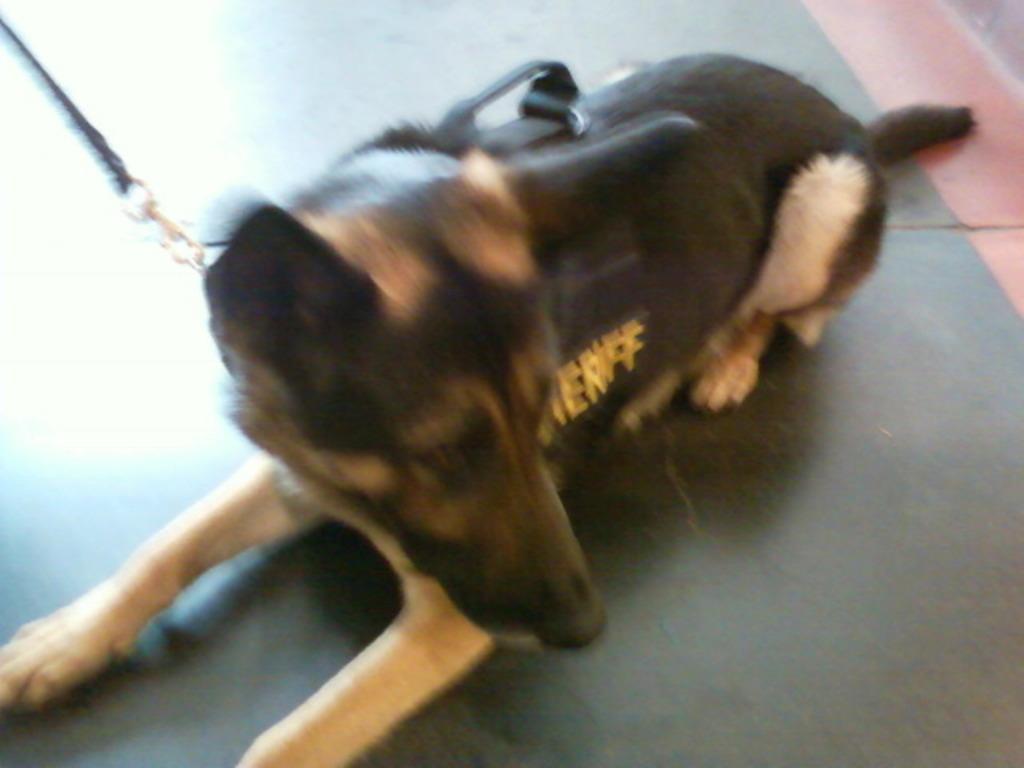Can you describe this image briefly? In this image there is a dog laid on the floor. 